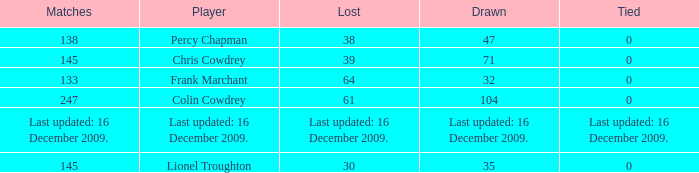Tell me the lost with tie of 0 and drawn of 47 38.0. 